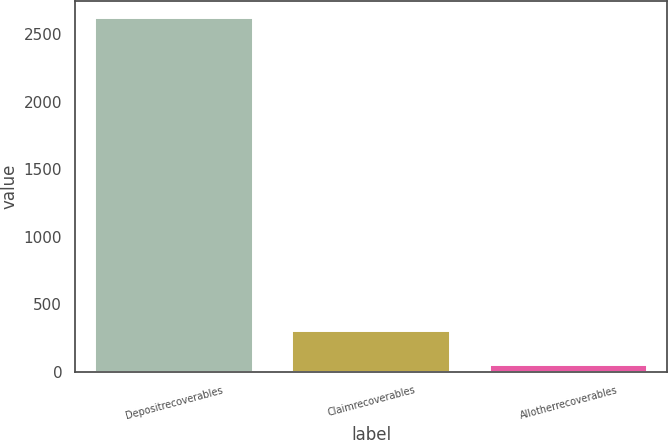Convert chart to OTSL. <chart><loc_0><loc_0><loc_500><loc_500><bar_chart><fcel>Depositrecoverables<fcel>Claimrecoverables<fcel>Allotherrecoverables<nl><fcel>2616<fcel>304.8<fcel>48<nl></chart> 